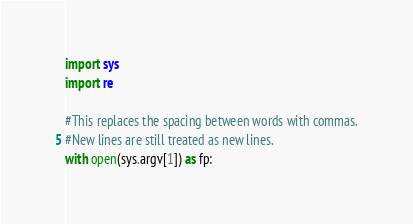Convert code to text. <code><loc_0><loc_0><loc_500><loc_500><_Python_>import sys
import re

#This replaces the spacing between words with commas.
#New lines are still treated as new lines.
with open(sys.argv[1]) as fp:</code> 